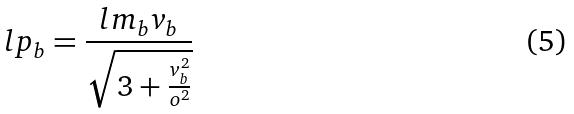Convert formula to latex. <formula><loc_0><loc_0><loc_500><loc_500>l p _ { b } = \frac { l m _ { b } v _ { b } } { \sqrt { 3 + \frac { v _ { b } ^ { 2 } } { o ^ { 2 } } } }</formula> 